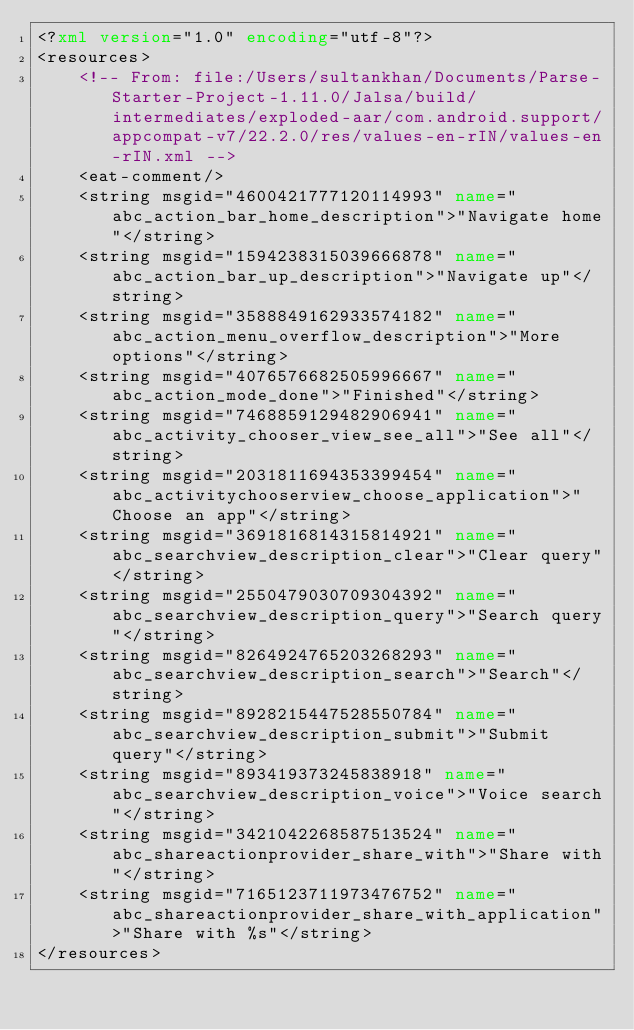Convert code to text. <code><loc_0><loc_0><loc_500><loc_500><_XML_><?xml version="1.0" encoding="utf-8"?>
<resources>
    <!-- From: file:/Users/sultankhan/Documents/Parse-Starter-Project-1.11.0/Jalsa/build/intermediates/exploded-aar/com.android.support/appcompat-v7/22.2.0/res/values-en-rIN/values-en-rIN.xml -->
    <eat-comment/>
    <string msgid="4600421777120114993" name="abc_action_bar_home_description">"Navigate home"</string>
    <string msgid="1594238315039666878" name="abc_action_bar_up_description">"Navigate up"</string>
    <string msgid="3588849162933574182" name="abc_action_menu_overflow_description">"More options"</string>
    <string msgid="4076576682505996667" name="abc_action_mode_done">"Finished"</string>
    <string msgid="7468859129482906941" name="abc_activity_chooser_view_see_all">"See all"</string>
    <string msgid="2031811694353399454" name="abc_activitychooserview_choose_application">"Choose an app"</string>
    <string msgid="3691816814315814921" name="abc_searchview_description_clear">"Clear query"</string>
    <string msgid="2550479030709304392" name="abc_searchview_description_query">"Search query"</string>
    <string msgid="8264924765203268293" name="abc_searchview_description_search">"Search"</string>
    <string msgid="8928215447528550784" name="abc_searchview_description_submit">"Submit query"</string>
    <string msgid="893419373245838918" name="abc_searchview_description_voice">"Voice search"</string>
    <string msgid="3421042268587513524" name="abc_shareactionprovider_share_with">"Share with"</string>
    <string msgid="7165123711973476752" name="abc_shareactionprovider_share_with_application">"Share with %s"</string>
</resources></code> 